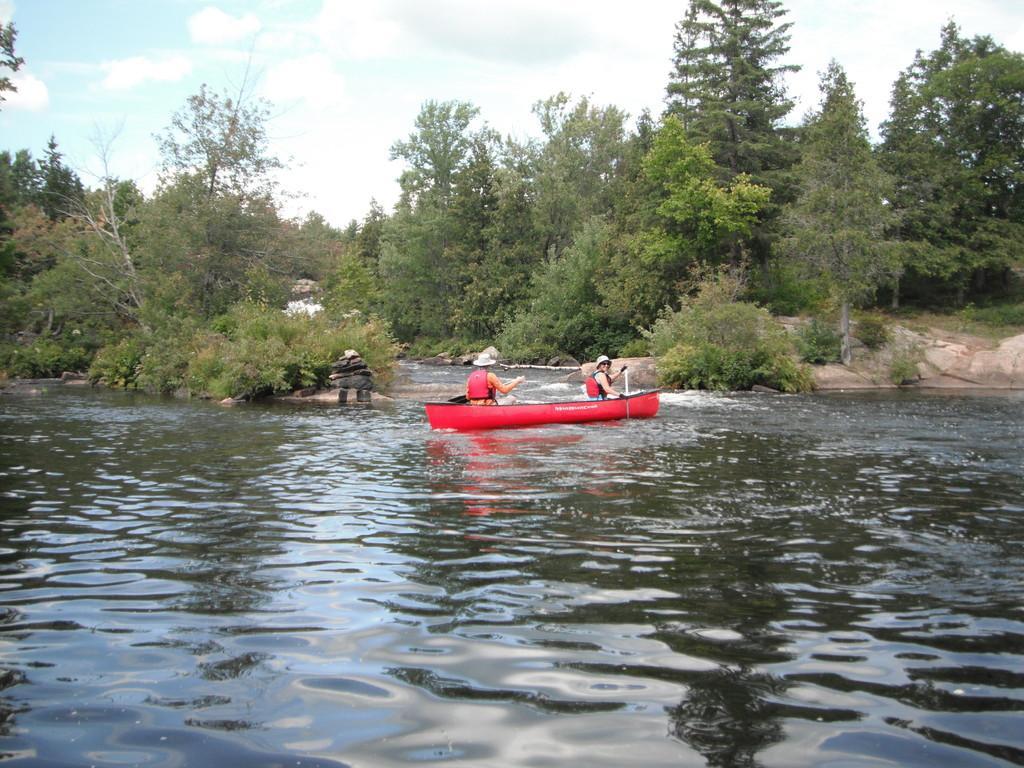Can you describe this image briefly? At the bottom of the image there is water. On the water there is a red boat with two people in it. In the background there are trees and also there are rocks. At the top of the image there is a sky. 